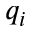Convert formula to latex. <formula><loc_0><loc_0><loc_500><loc_500>q _ { i }</formula> 